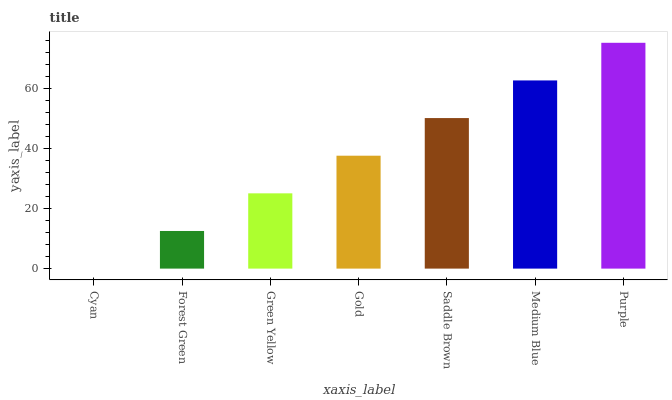Is Cyan the minimum?
Answer yes or no. Yes. Is Purple the maximum?
Answer yes or no. Yes. Is Forest Green the minimum?
Answer yes or no. No. Is Forest Green the maximum?
Answer yes or no. No. Is Forest Green greater than Cyan?
Answer yes or no. Yes. Is Cyan less than Forest Green?
Answer yes or no. Yes. Is Cyan greater than Forest Green?
Answer yes or no. No. Is Forest Green less than Cyan?
Answer yes or no. No. Is Gold the high median?
Answer yes or no. Yes. Is Gold the low median?
Answer yes or no. Yes. Is Green Yellow the high median?
Answer yes or no. No. Is Saddle Brown the low median?
Answer yes or no. No. 